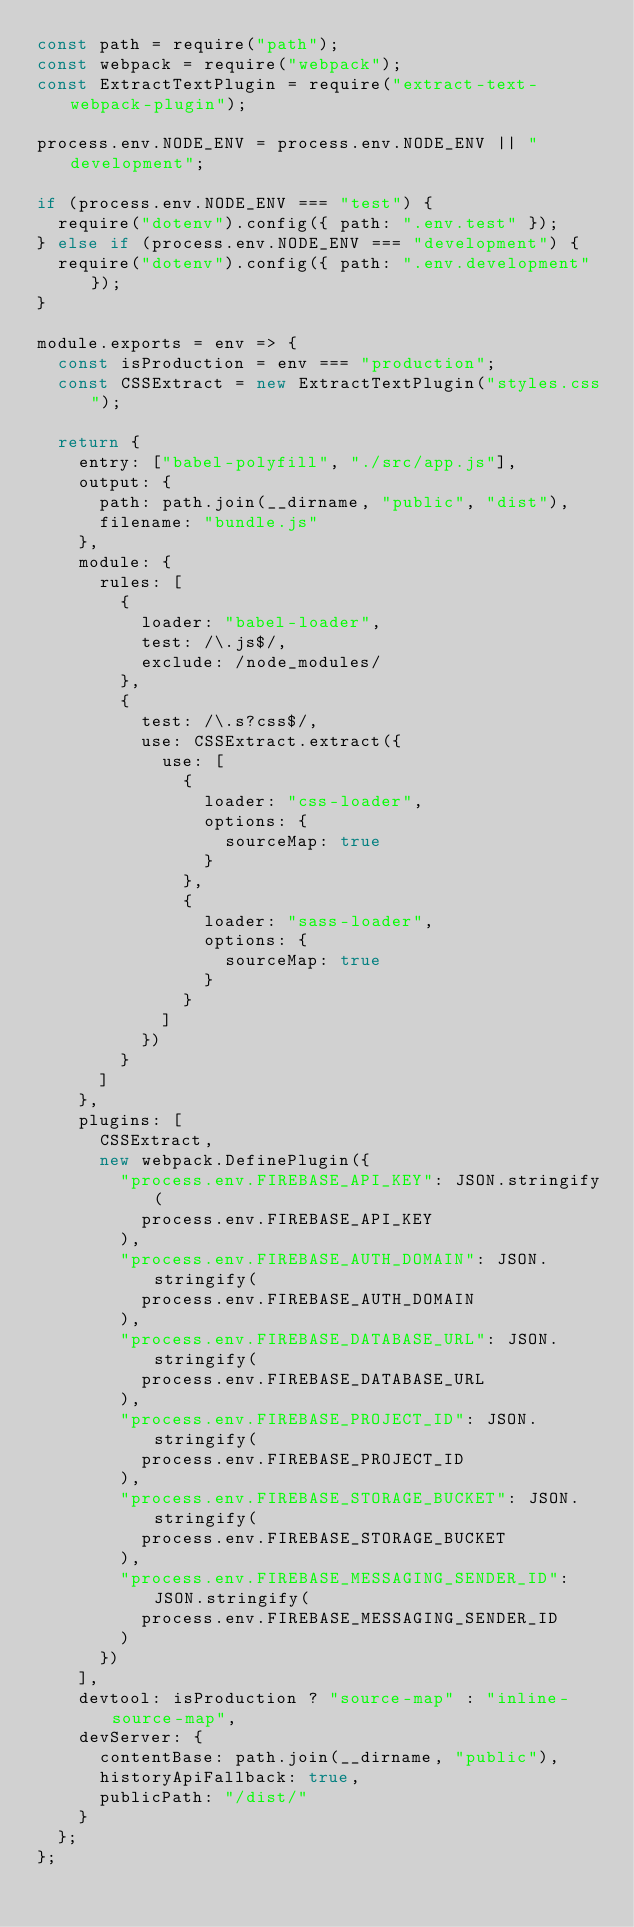Convert code to text. <code><loc_0><loc_0><loc_500><loc_500><_JavaScript_>const path = require("path");
const webpack = require("webpack");
const ExtractTextPlugin = require("extract-text-webpack-plugin");

process.env.NODE_ENV = process.env.NODE_ENV || "development";

if (process.env.NODE_ENV === "test") {
  require("dotenv").config({ path: ".env.test" });
} else if (process.env.NODE_ENV === "development") {
  require("dotenv").config({ path: ".env.development" });
}

module.exports = env => {
  const isProduction = env === "production";
  const CSSExtract = new ExtractTextPlugin("styles.css");

  return {
    entry: ["babel-polyfill", "./src/app.js"],
    output: {
      path: path.join(__dirname, "public", "dist"),
      filename: "bundle.js"
    },
    module: {
      rules: [
        {
          loader: "babel-loader",
          test: /\.js$/,
          exclude: /node_modules/
        },
        {
          test: /\.s?css$/,
          use: CSSExtract.extract({
            use: [
              {
                loader: "css-loader",
                options: {
                  sourceMap: true
                }
              },
              {
                loader: "sass-loader",
                options: {
                  sourceMap: true
                }
              }
            ]
          })
        }
      ]
    },
    plugins: [
      CSSExtract,
      new webpack.DefinePlugin({
        "process.env.FIREBASE_API_KEY": JSON.stringify(
          process.env.FIREBASE_API_KEY
        ),
        "process.env.FIREBASE_AUTH_DOMAIN": JSON.stringify(
          process.env.FIREBASE_AUTH_DOMAIN
        ),
        "process.env.FIREBASE_DATABASE_URL": JSON.stringify(
          process.env.FIREBASE_DATABASE_URL
        ),
        "process.env.FIREBASE_PROJECT_ID": JSON.stringify(
          process.env.FIREBASE_PROJECT_ID
        ),
        "process.env.FIREBASE_STORAGE_BUCKET": JSON.stringify(
          process.env.FIREBASE_STORAGE_BUCKET
        ),
        "process.env.FIREBASE_MESSAGING_SENDER_ID": JSON.stringify(
          process.env.FIREBASE_MESSAGING_SENDER_ID
        )
      })
    ],
    devtool: isProduction ? "source-map" : "inline-source-map",
    devServer: {
      contentBase: path.join(__dirname, "public"),
      historyApiFallback: true,
      publicPath: "/dist/"
    }
  };
};
</code> 